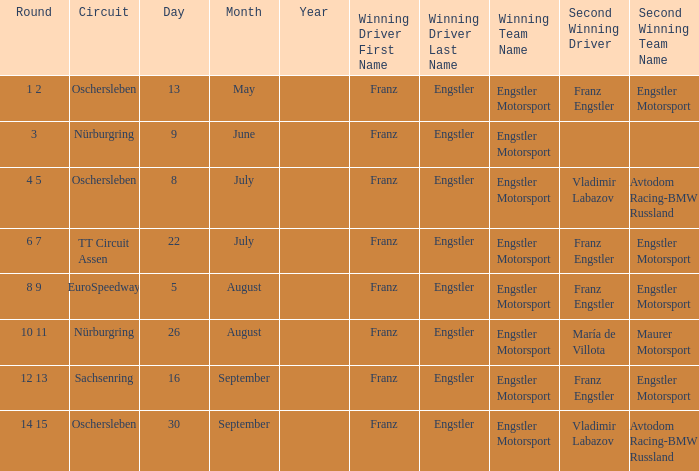What Round was the Winning Team Engstler Motorsport Maurer Motorsport? 10 11. 